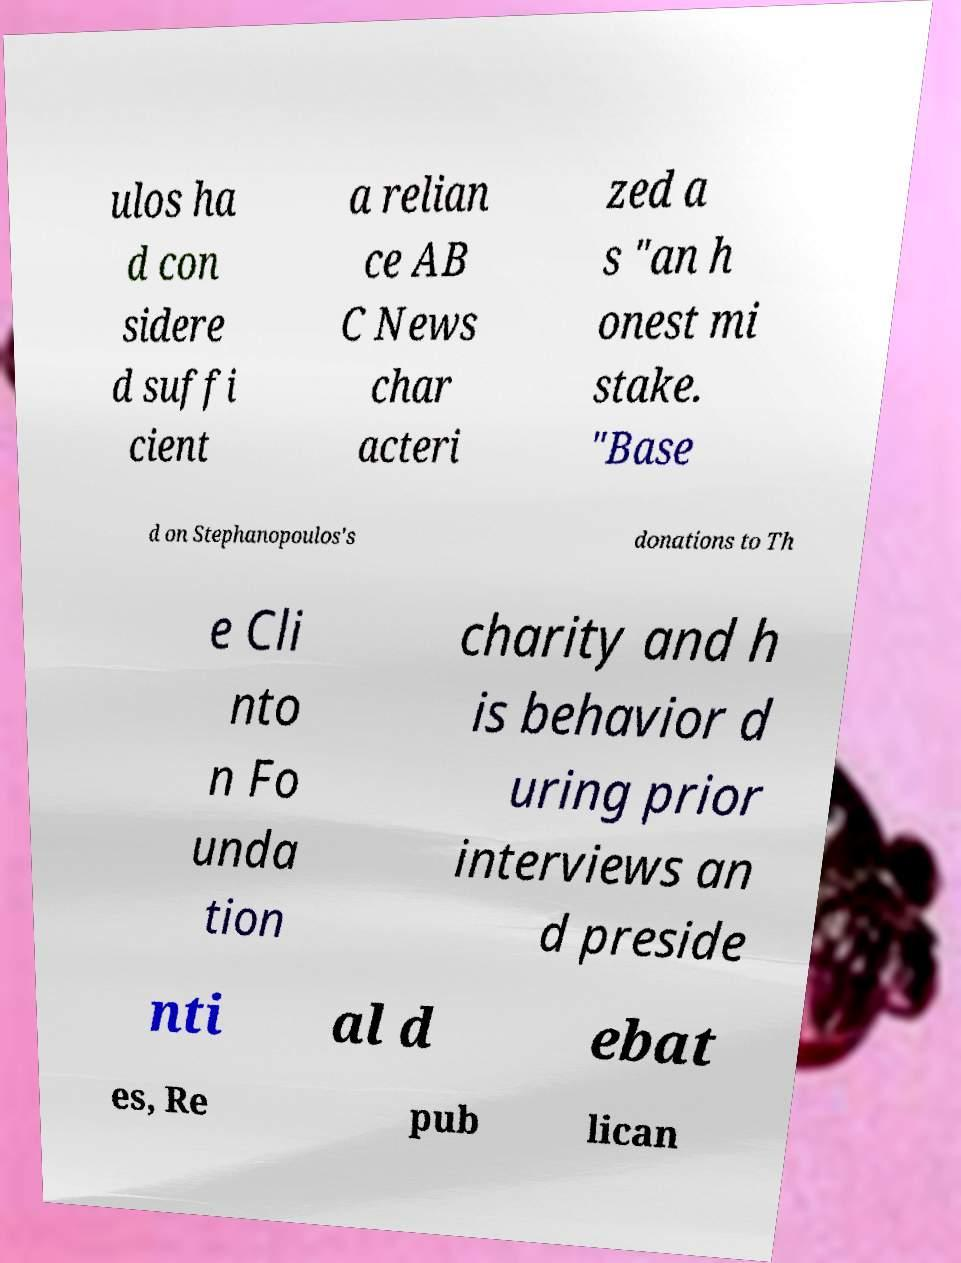Can you accurately transcribe the text from the provided image for me? ulos ha d con sidere d suffi cient a relian ce AB C News char acteri zed a s "an h onest mi stake. "Base d on Stephanopoulos's donations to Th e Cli nto n Fo unda tion charity and h is behavior d uring prior interviews an d preside nti al d ebat es, Re pub lican 